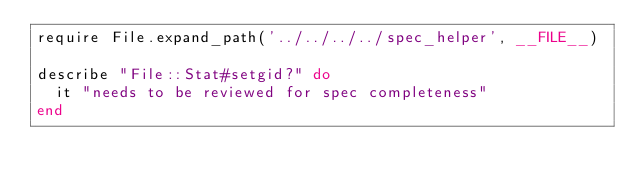<code> <loc_0><loc_0><loc_500><loc_500><_Ruby_>require File.expand_path('../../../../spec_helper', __FILE__)

describe "File::Stat#setgid?" do
  it "needs to be reviewed for spec completeness"
end
</code> 